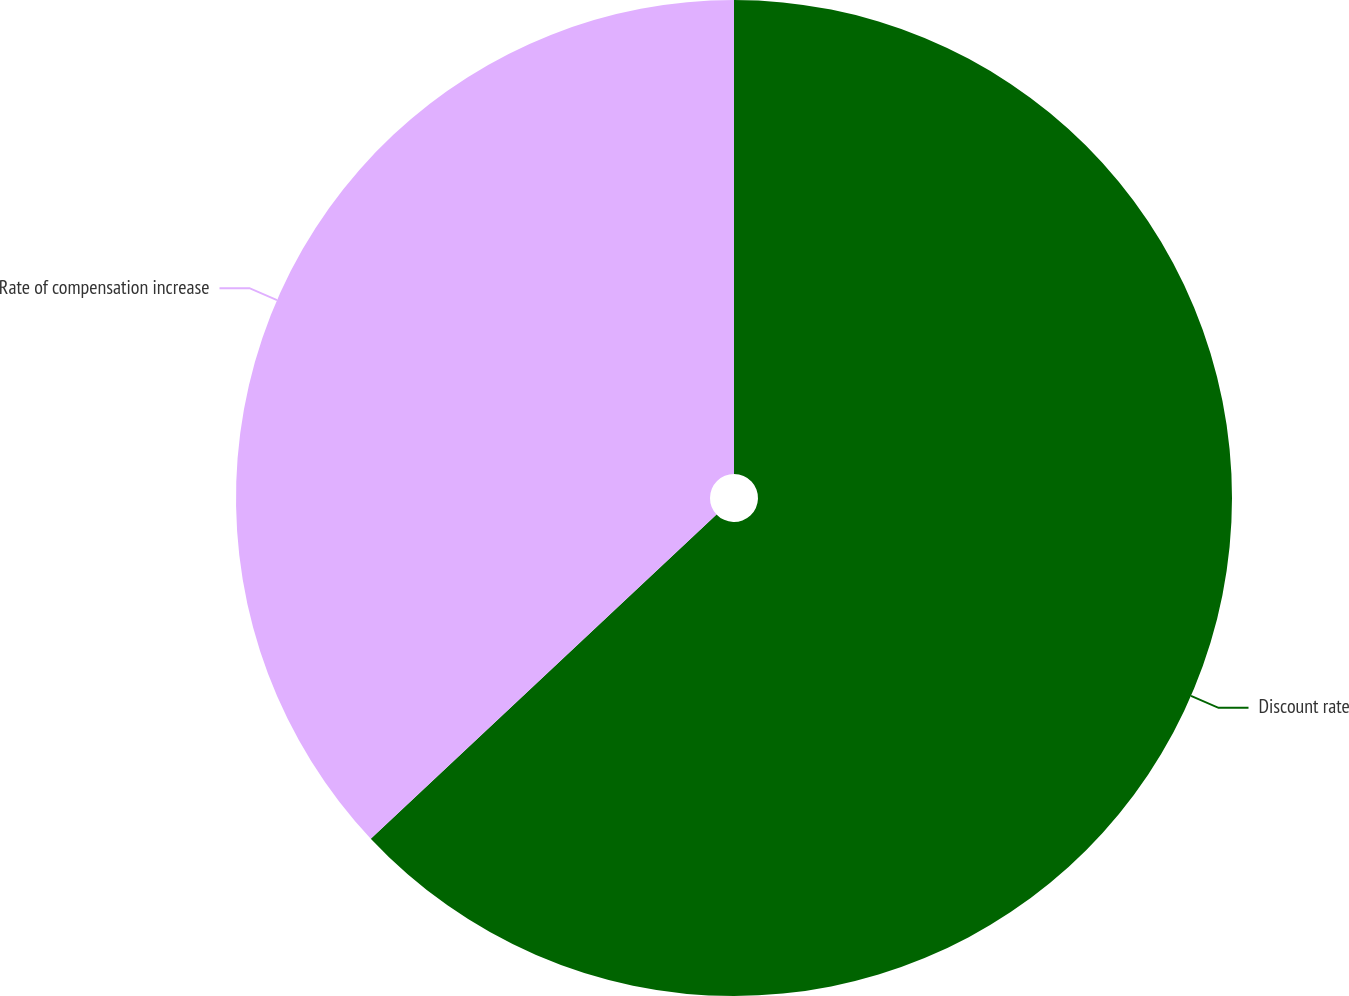<chart> <loc_0><loc_0><loc_500><loc_500><pie_chart><fcel>Discount rate<fcel>Rate of compensation increase<nl><fcel>63.01%<fcel>36.99%<nl></chart> 